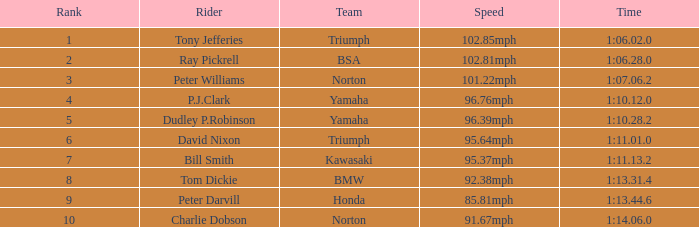76mph velocity, what is the duration? 1:10.12.0. 